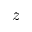<formula> <loc_0><loc_0><loc_500><loc_500>z</formula> 